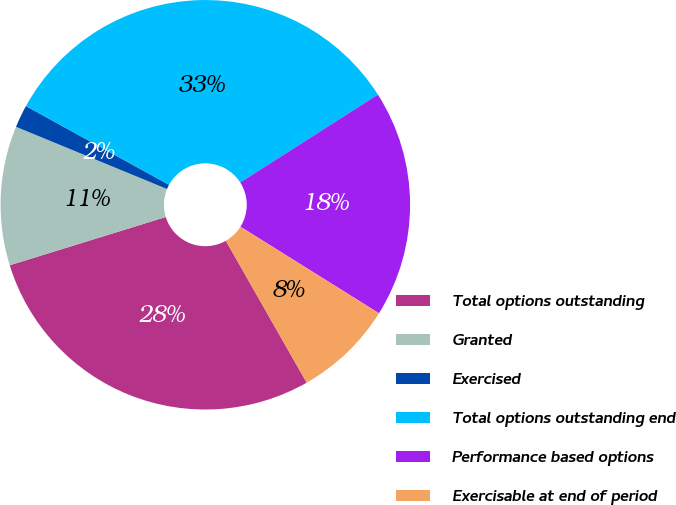Convert chart. <chart><loc_0><loc_0><loc_500><loc_500><pie_chart><fcel>Total options outstanding<fcel>Granted<fcel>Exercised<fcel>Total options outstanding end<fcel>Performance based options<fcel>Exercisable at end of period<nl><fcel>28.47%<fcel>10.99%<fcel>1.79%<fcel>32.95%<fcel>17.93%<fcel>7.87%<nl></chart> 